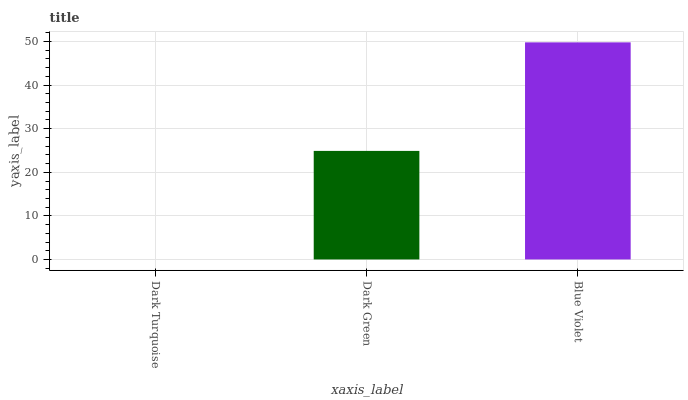Is Dark Turquoise the minimum?
Answer yes or no. Yes. Is Blue Violet the maximum?
Answer yes or no. Yes. Is Dark Green the minimum?
Answer yes or no. No. Is Dark Green the maximum?
Answer yes or no. No. Is Dark Green greater than Dark Turquoise?
Answer yes or no. Yes. Is Dark Turquoise less than Dark Green?
Answer yes or no. Yes. Is Dark Turquoise greater than Dark Green?
Answer yes or no. No. Is Dark Green less than Dark Turquoise?
Answer yes or no. No. Is Dark Green the high median?
Answer yes or no. Yes. Is Dark Green the low median?
Answer yes or no. Yes. Is Dark Turquoise the high median?
Answer yes or no. No. Is Dark Turquoise the low median?
Answer yes or no. No. 